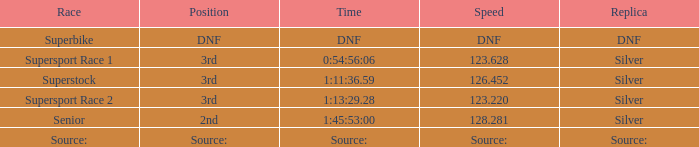Which race holds a 3rd place and a velocity of 12 Superstock. 